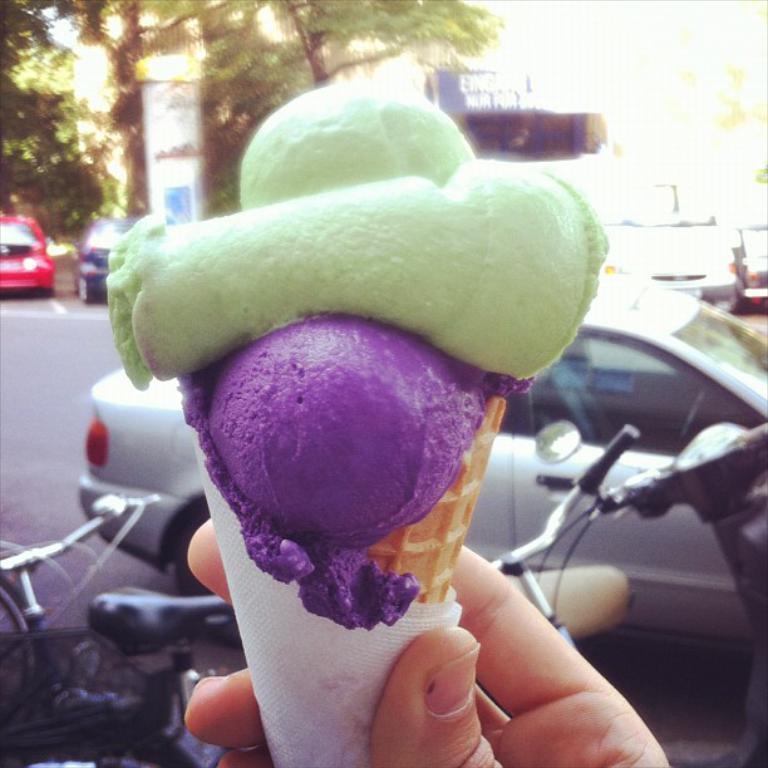Can you describe this image briefly? In this image at the bottom, there is a person hand holding a cone ice cream and tissues. In the middle there are cars, cycles, trees, buildings and road. 